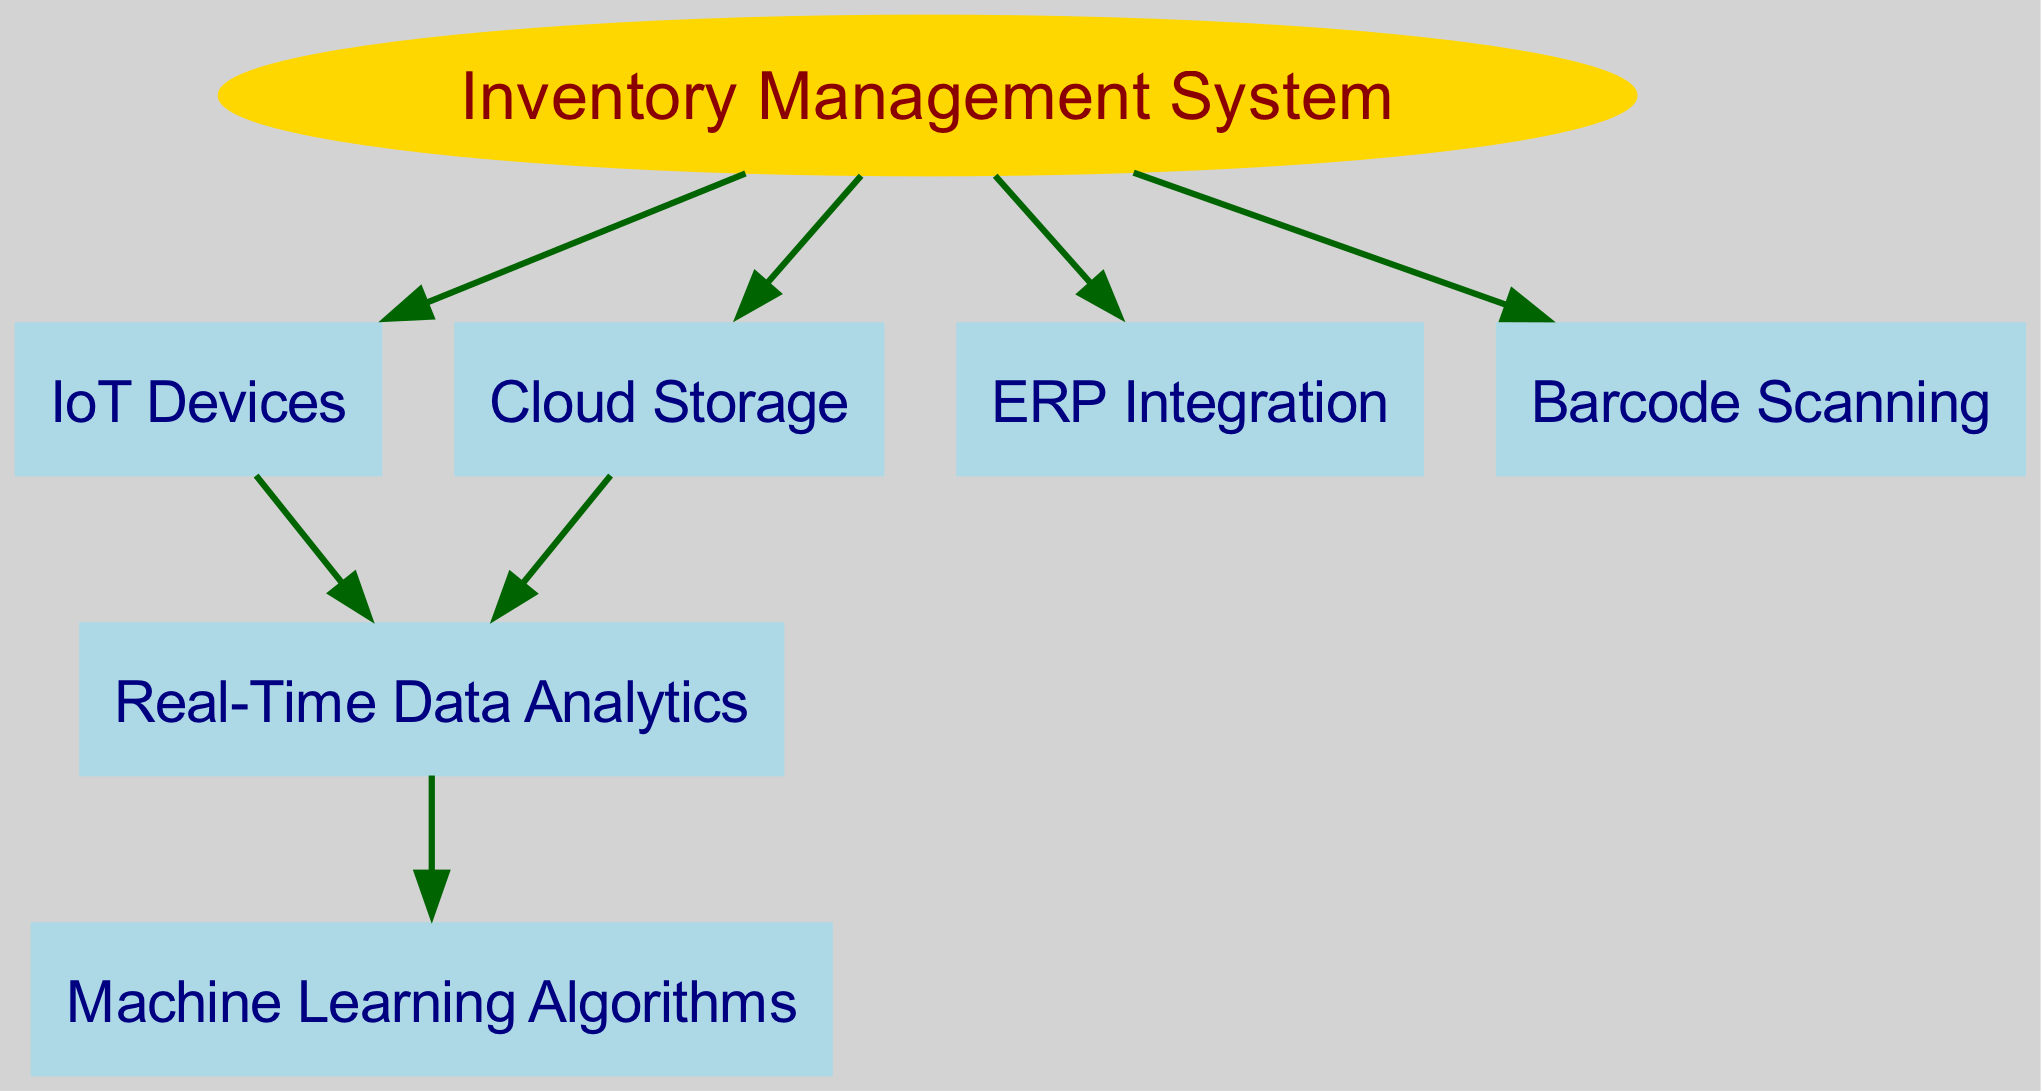What is the central node of the diagram? The central node, representing the main system, is labeled "Inventory Management System." This is determined by identifying the node indicated as an ellipse and colored in gold, which is the key focus of the diagram.
Answer: Inventory Management System How many nodes are present in the diagram? By counting each unique node listed in the data, we find a total of six nodes including "Inventory Management System," "IoT Devices," "Cloud Storage," "Real-Time Data Analytics," "ERP Integration," and "Barcode Scanning." Therefore, the total is six.
Answer: 6 What connects IoT Devices to Real-Time Data Analytics? The edge connecting "IoT Devices" to "Real-Time Data Analytics" indicates a direct relationship where real-time data analytics benefit from information collected by IoT devices. This connection can be confirmed by locating the edge between the two nodes in the graph.
Answer: Real-Time Data Analytics Which technology integrates with the Inventory Management System for direct operational use? The nodes connected to the "Inventory Management System" include "ERP Integration" and "Barcode Scanning," indicating that both technologies work directly with the inventory system to streamline processes. Therefore, either of these can be correct, but focusing on the type of integration is key.
Answer: ERP Integration How many edges are drawn from the Inventory Management System? By examining the connections or edges drawn from the "Inventory Management System," we can count that there are four edges leading to "IoT Devices," "Cloud Storage," "ERP Integration," and "Barcode Scanning." Thus, the total here is four edges.
Answer: 4 What role does Real-Time Data Analytics play in relation to Machine Learning Algorithms? The edge connecting "Real-Time Data Analytics" to "Machine Learning Algorithms" signifies that insights generated from real-time analytics can be utilized for machine learning applications, indicating a dependency where real-time data informs machine learning models. This relationship is easily seen from the arrows in the diagram.
Answer: Machine Learning Algorithms Which node is directly influenced by both IoT Devices and Cloud Storage? The node that is influenced by both "IoT Devices" and "Cloud Storage" is "Real-Time Data Analytics," as there are edges coming from each of these nodes pointing towards it, making it a significant hub for gathering and processing data. This can be verified by tracing the connections in the diagram.
Answer: Real-Time Data Analytics Is there a node that connects to both IoT Devices and Cloud Storage? Yes, the "Real-Time Data Analytics" node connects to both "IoT Devices" and "Cloud Storage," as indicated by the edges leading into it from these two nodes. This shows its role in consolidating data from multiple sources.
Answer: Real-Time Data Analytics Which node shows a direct utilization in the system for scanning operations? The node labeled "Barcode Scanning" is specifically designated to indicate a technology used for scanning operations directly connected to the inventory management system. This is clear from the direct edge connecting it with the central node.
Answer: Barcode Scanning 